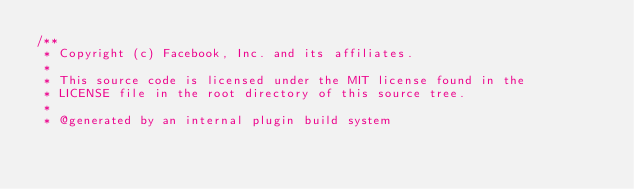<code> <loc_0><loc_0><loc_500><loc_500><_C_>/**
 * Copyright (c) Facebook, Inc. and its affiliates.
 *
 * This source code is licensed under the MIT license found in the
 * LICENSE file in the root directory of this source tree.
 *
 * @generated by an internal plugin build system</code> 